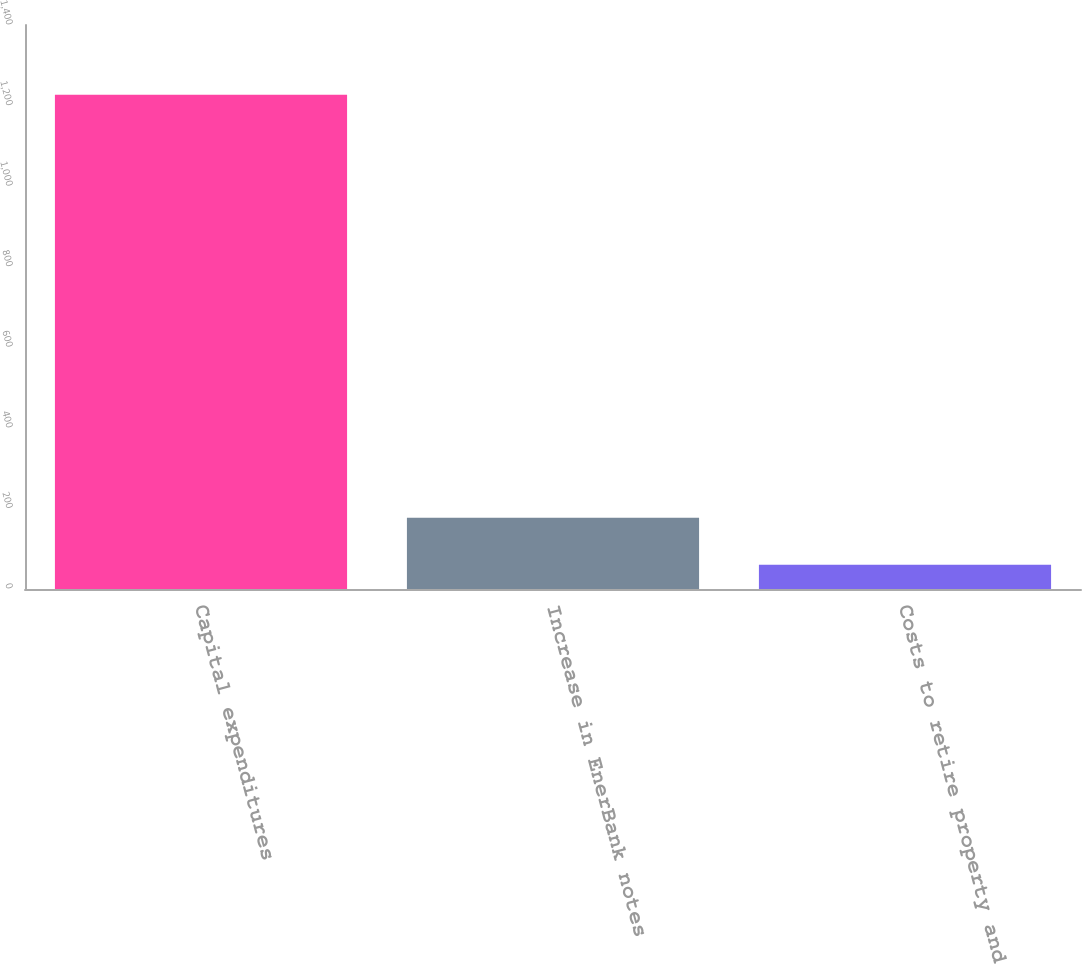<chart> <loc_0><loc_0><loc_500><loc_500><bar_chart><fcel>Capital expenditures<fcel>Increase in EnerBank notes<fcel>Costs to retire property and<nl><fcel>1227<fcel>176.7<fcel>60<nl></chart> 